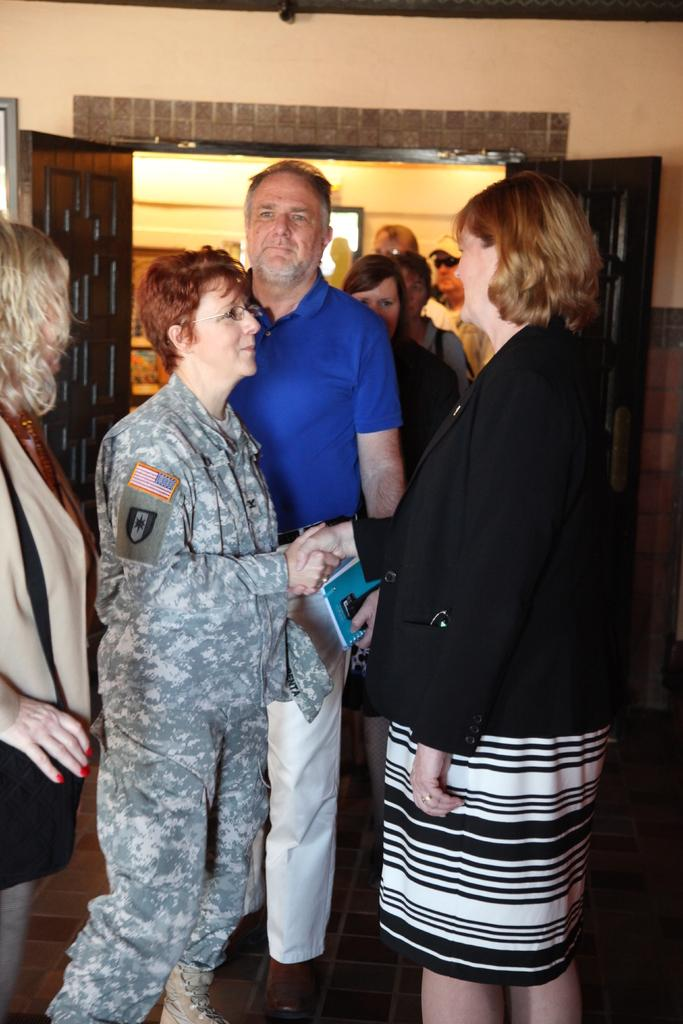What is happening in the image? There is a group of people standing in the image. What can be seen in the background of the image? There are doors visible in the background of the image, as well as other unspecified objects. What type of spark can be seen coming from the chin of the person in the image? There is no spark or any indication of a spark in the image. 